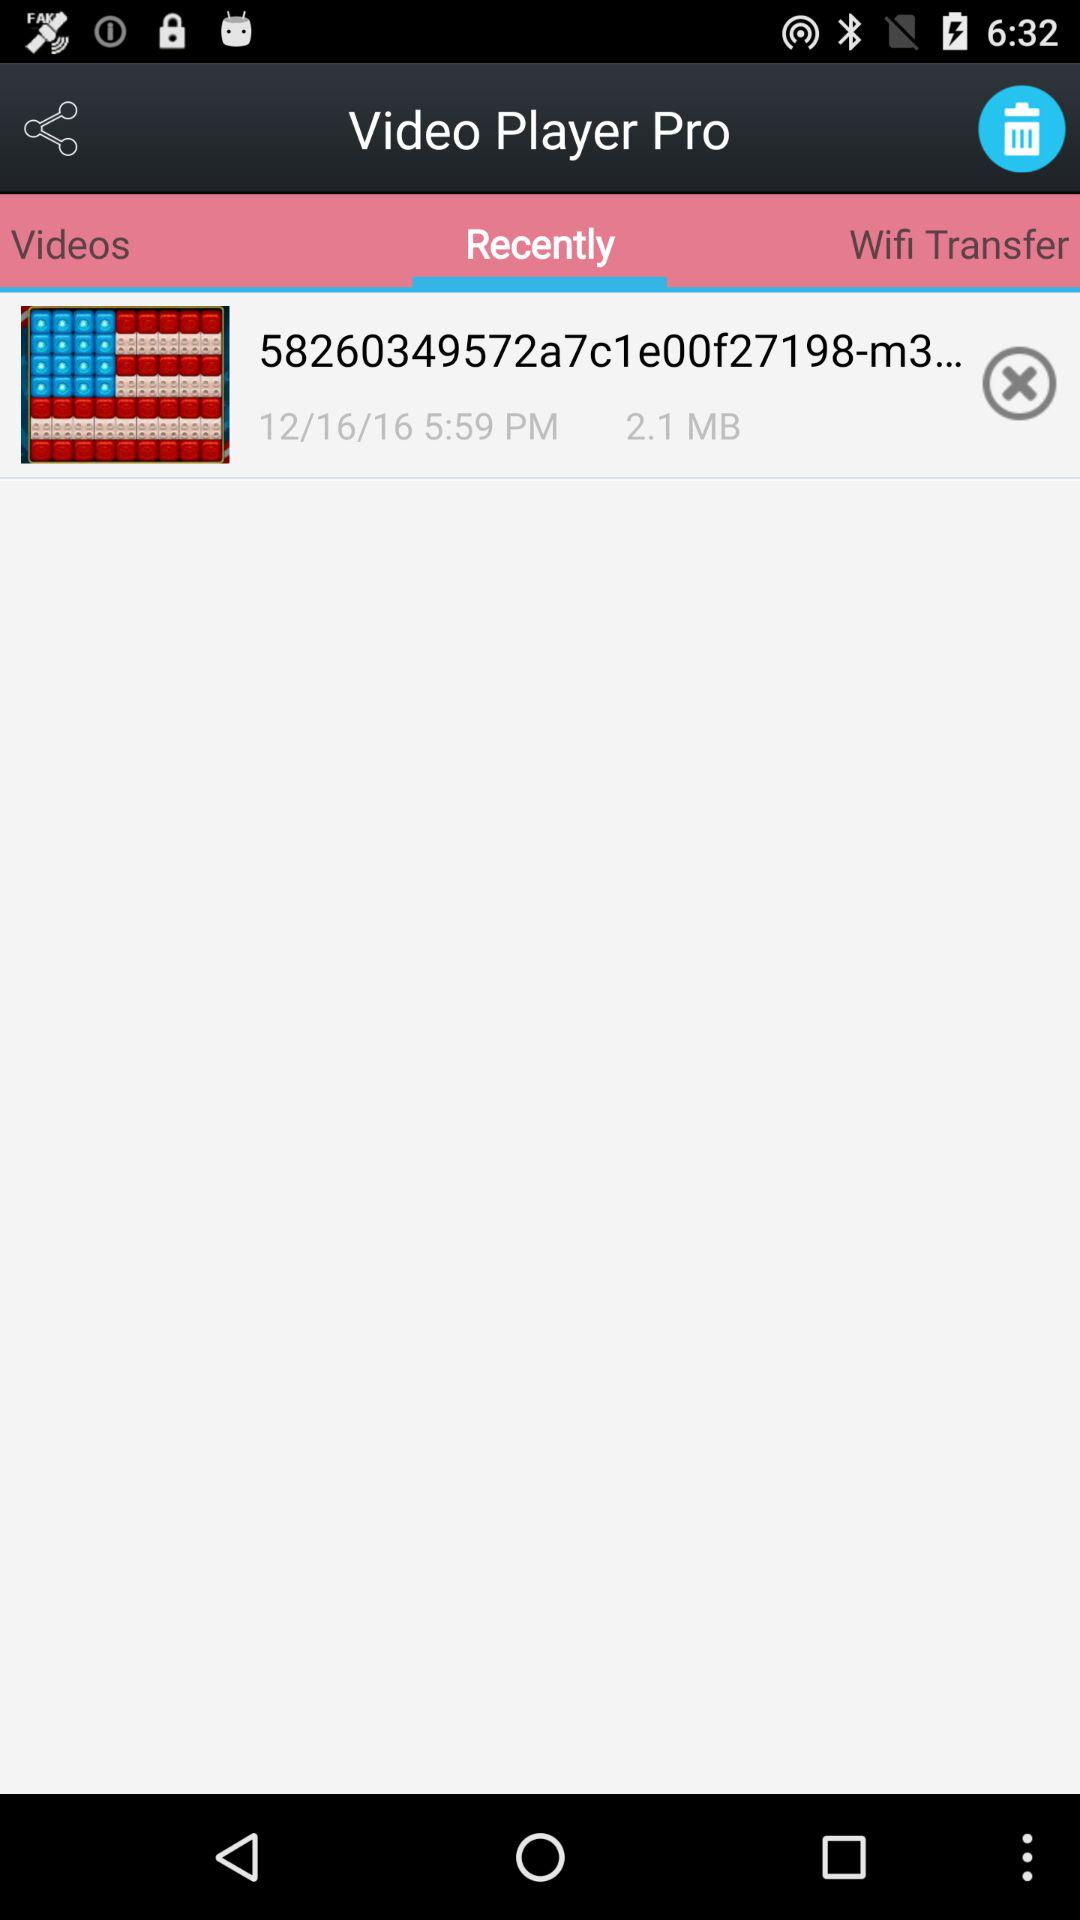At what time is the video saved? The video is saved at 5:59 PM. 